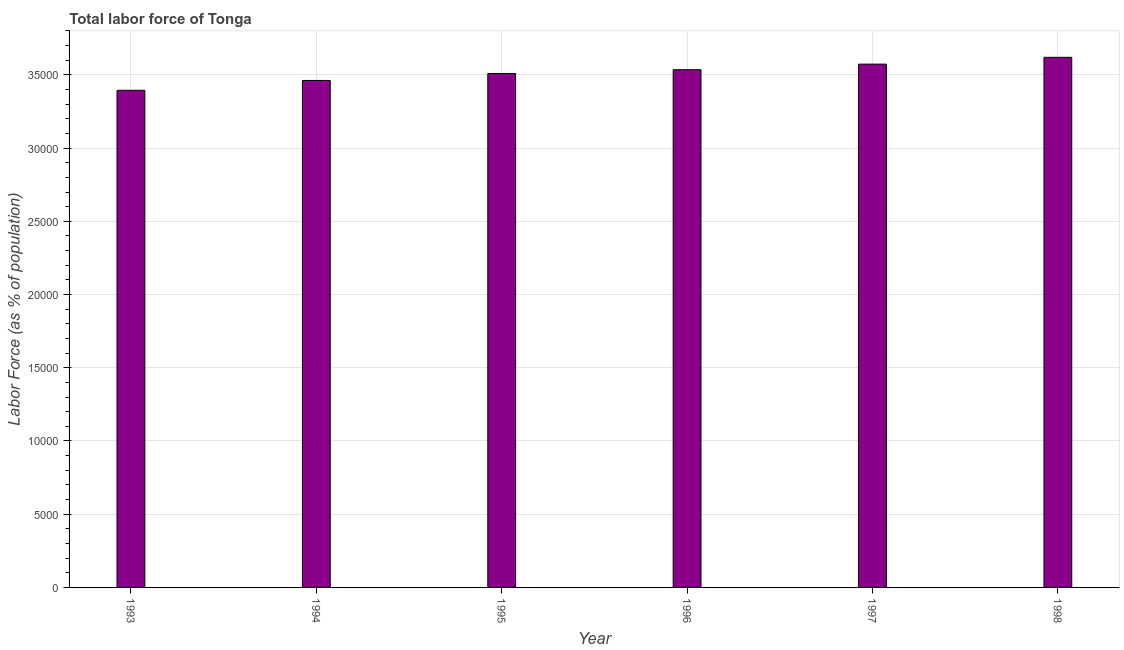What is the title of the graph?
Make the answer very short. Total labor force of Tonga. What is the label or title of the X-axis?
Your response must be concise. Year. What is the label or title of the Y-axis?
Keep it short and to the point. Labor Force (as % of population). What is the total labor force in 1997?
Keep it short and to the point. 3.57e+04. Across all years, what is the maximum total labor force?
Provide a short and direct response. 3.62e+04. Across all years, what is the minimum total labor force?
Provide a short and direct response. 3.39e+04. In which year was the total labor force maximum?
Provide a short and direct response. 1998. In which year was the total labor force minimum?
Your answer should be very brief. 1993. What is the sum of the total labor force?
Offer a very short reply. 2.11e+05. What is the difference between the total labor force in 1993 and 1994?
Keep it short and to the point. -672. What is the average total labor force per year?
Offer a very short reply. 3.52e+04. What is the median total labor force?
Give a very brief answer. 3.52e+04. In how many years, is the total labor force greater than 6000 %?
Make the answer very short. 6. Is the total labor force in 1997 less than that in 1998?
Give a very brief answer. Yes. What is the difference between the highest and the second highest total labor force?
Offer a very short reply. 465. Is the sum of the total labor force in 1997 and 1998 greater than the maximum total labor force across all years?
Provide a succinct answer. Yes. What is the difference between the highest and the lowest total labor force?
Provide a succinct answer. 2252. In how many years, is the total labor force greater than the average total labor force taken over all years?
Make the answer very short. 3. How many bars are there?
Your answer should be very brief. 6. Are all the bars in the graph horizontal?
Offer a very short reply. No. How many years are there in the graph?
Make the answer very short. 6. What is the difference between two consecutive major ticks on the Y-axis?
Provide a short and direct response. 5000. What is the Labor Force (as % of population) in 1993?
Ensure brevity in your answer.  3.39e+04. What is the Labor Force (as % of population) in 1994?
Your answer should be compact. 3.46e+04. What is the Labor Force (as % of population) in 1995?
Give a very brief answer. 3.51e+04. What is the Labor Force (as % of population) in 1996?
Your response must be concise. 3.54e+04. What is the Labor Force (as % of population) in 1997?
Provide a succinct answer. 3.57e+04. What is the Labor Force (as % of population) of 1998?
Your answer should be compact. 3.62e+04. What is the difference between the Labor Force (as % of population) in 1993 and 1994?
Give a very brief answer. -672. What is the difference between the Labor Force (as % of population) in 1993 and 1995?
Provide a succinct answer. -1148. What is the difference between the Labor Force (as % of population) in 1993 and 1996?
Offer a terse response. -1406. What is the difference between the Labor Force (as % of population) in 1993 and 1997?
Keep it short and to the point. -1787. What is the difference between the Labor Force (as % of population) in 1993 and 1998?
Provide a short and direct response. -2252. What is the difference between the Labor Force (as % of population) in 1994 and 1995?
Your response must be concise. -476. What is the difference between the Labor Force (as % of population) in 1994 and 1996?
Make the answer very short. -734. What is the difference between the Labor Force (as % of population) in 1994 and 1997?
Give a very brief answer. -1115. What is the difference between the Labor Force (as % of population) in 1994 and 1998?
Offer a very short reply. -1580. What is the difference between the Labor Force (as % of population) in 1995 and 1996?
Provide a short and direct response. -258. What is the difference between the Labor Force (as % of population) in 1995 and 1997?
Your answer should be compact. -639. What is the difference between the Labor Force (as % of population) in 1995 and 1998?
Offer a very short reply. -1104. What is the difference between the Labor Force (as % of population) in 1996 and 1997?
Make the answer very short. -381. What is the difference between the Labor Force (as % of population) in 1996 and 1998?
Provide a short and direct response. -846. What is the difference between the Labor Force (as % of population) in 1997 and 1998?
Provide a succinct answer. -465. What is the ratio of the Labor Force (as % of population) in 1993 to that in 1997?
Make the answer very short. 0.95. What is the ratio of the Labor Force (as % of population) in 1993 to that in 1998?
Keep it short and to the point. 0.94. What is the ratio of the Labor Force (as % of population) in 1994 to that in 1996?
Your answer should be compact. 0.98. What is the ratio of the Labor Force (as % of population) in 1994 to that in 1998?
Keep it short and to the point. 0.96. What is the ratio of the Labor Force (as % of population) in 1997 to that in 1998?
Provide a short and direct response. 0.99. 